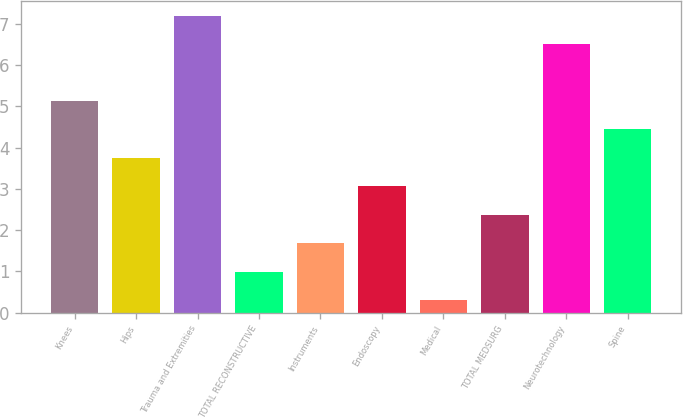Convert chart to OTSL. <chart><loc_0><loc_0><loc_500><loc_500><bar_chart><fcel>Knees<fcel>Hips<fcel>Trauma and Extremities<fcel>TOTAL RECONSTRUCTIVE<fcel>Instruments<fcel>Endoscopy<fcel>Medical<fcel>TOTAL MEDSURG<fcel>Neurotechnology<fcel>Spine<nl><fcel>5.13<fcel>3.75<fcel>7.2<fcel>0.99<fcel>1.68<fcel>3.06<fcel>0.3<fcel>2.37<fcel>6.51<fcel>4.44<nl></chart> 